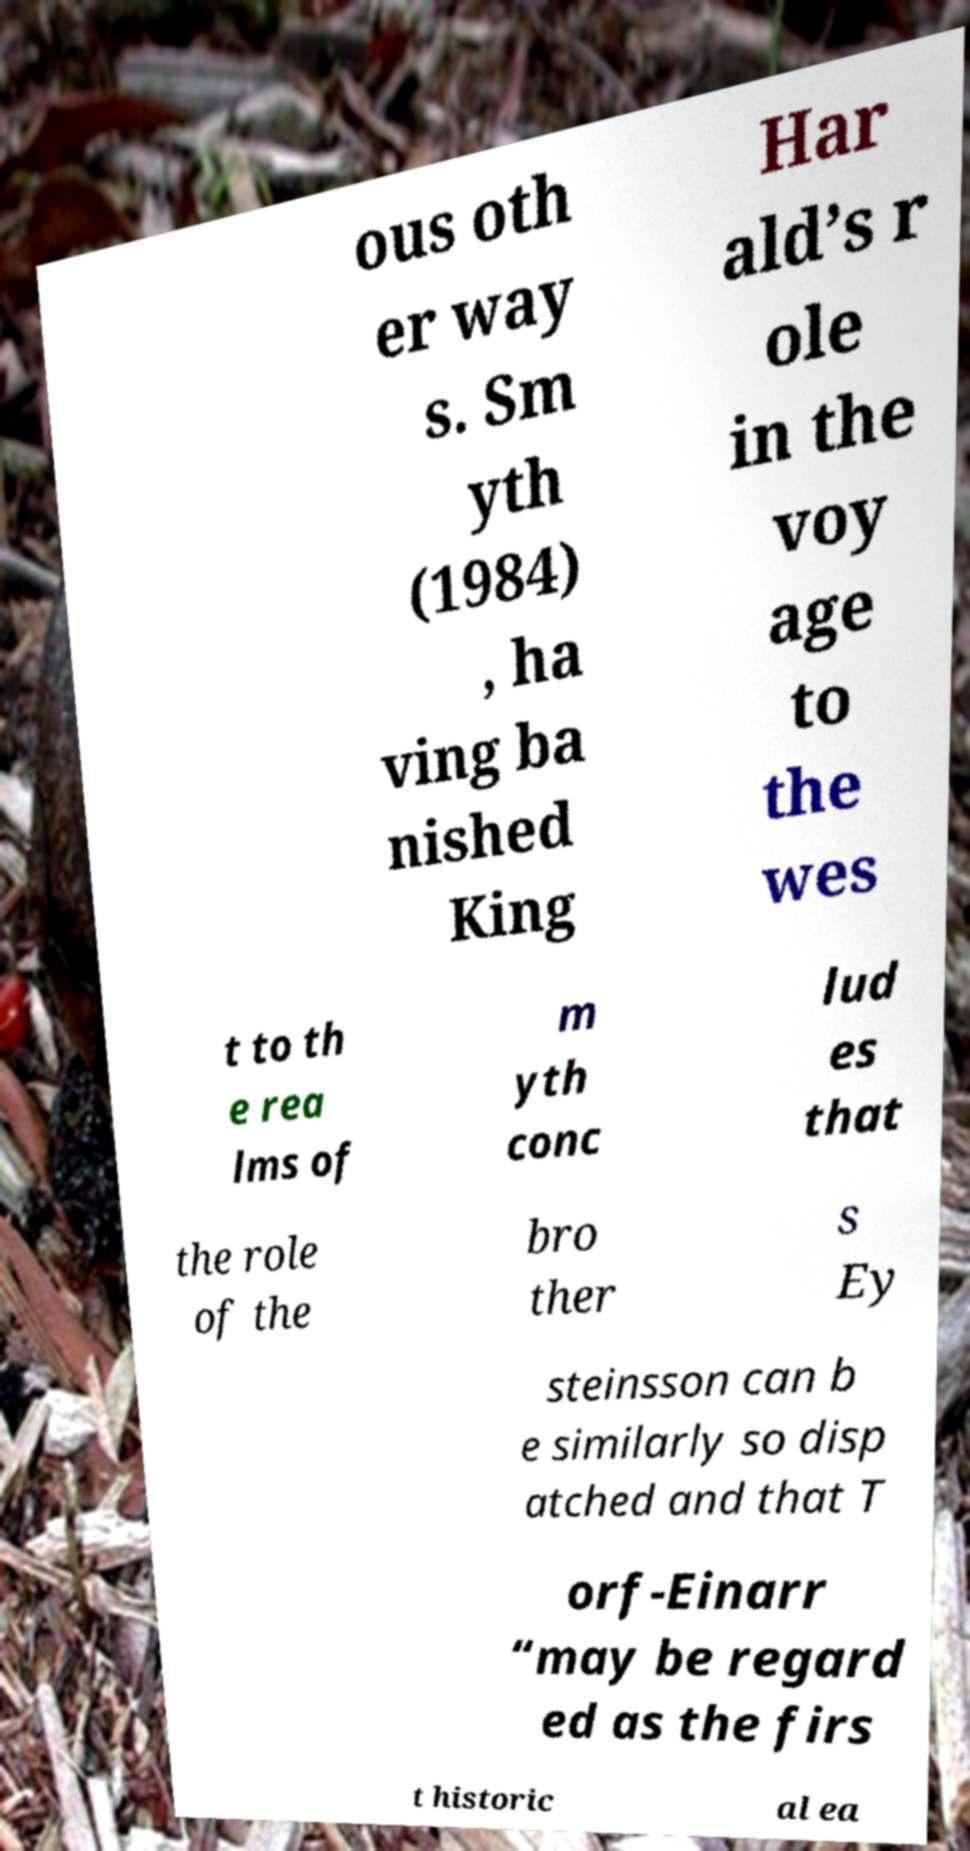Please read and relay the text visible in this image. What does it say? ous oth er way s. Sm yth (1984) , ha ving ba nished King Har ald’s r ole in the voy age to the wes t to th e rea lms of m yth conc lud es that the role of the bro ther s Ey steinsson can b e similarly so disp atched and that T orf-Einarr “may be regard ed as the firs t historic al ea 